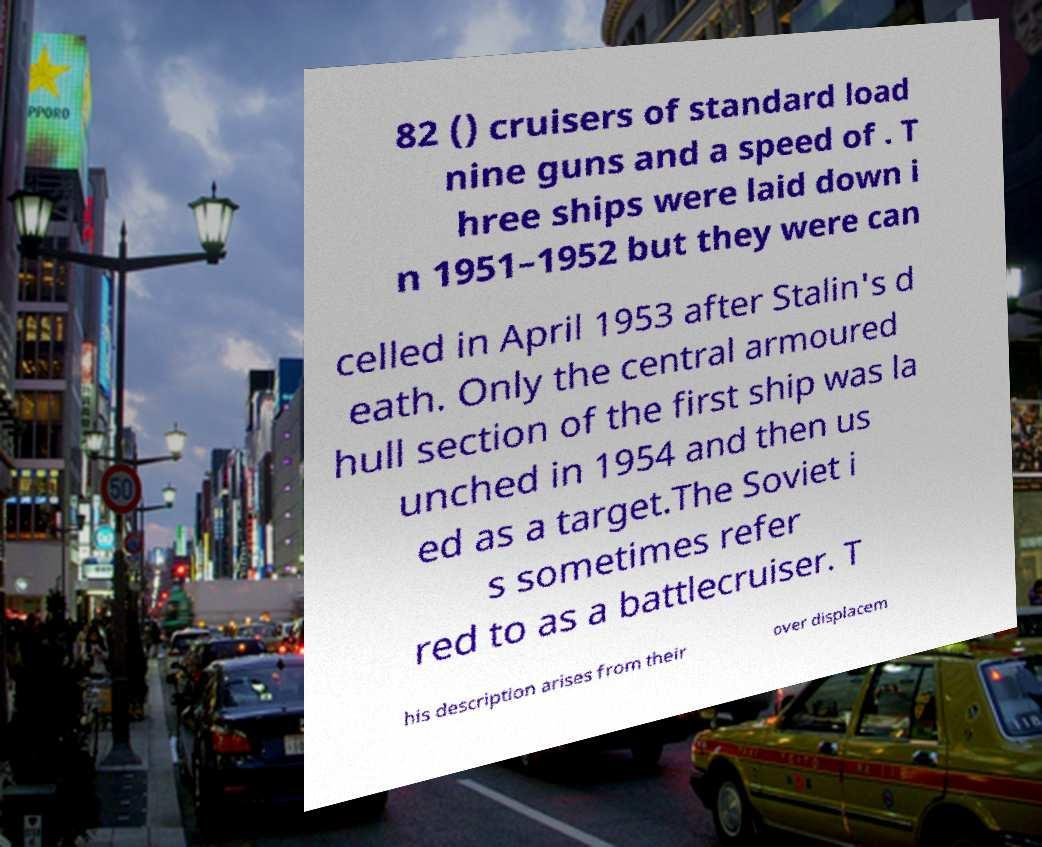What messages or text are displayed in this image? I need them in a readable, typed format. 82 () cruisers of standard load nine guns and a speed of . T hree ships were laid down i n 1951–1952 but they were can celled in April 1953 after Stalin's d eath. Only the central armoured hull section of the first ship was la unched in 1954 and then us ed as a target.The Soviet i s sometimes refer red to as a battlecruiser. T his description arises from their over displacem 